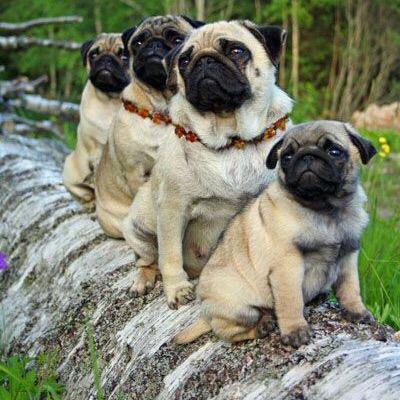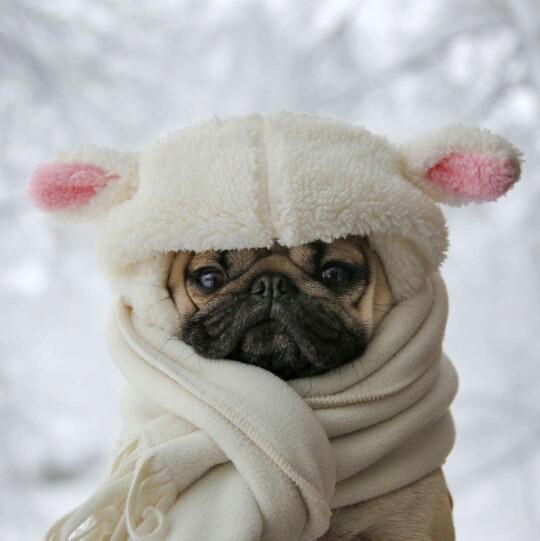The first image is the image on the left, the second image is the image on the right. Assess this claim about the two images: "A dog is shown near some sheep.". Correct or not? Answer yes or no. No. The first image is the image on the left, the second image is the image on the right. Given the left and right images, does the statement "Only one of the images shows a dog wearing animal-themed attire." hold true? Answer yes or no. Yes. 